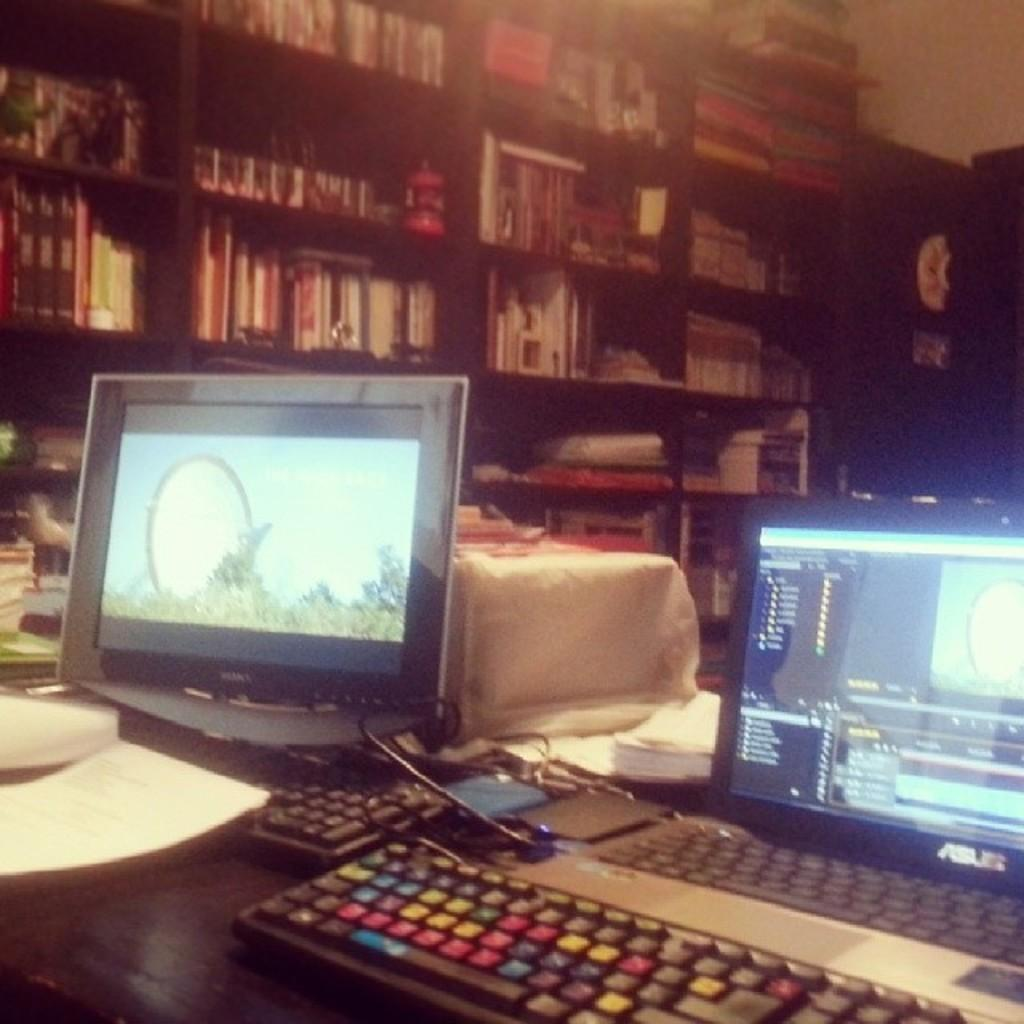What objects can be seen in the image? There are books, a table, laptops, and keyboards in the image. What surface are the laptops and keyboards placed on? The laptops and keyboards are placed on a table in the image. What might be used for typing or inputting information in the image? The keyboards on the table can be used for typing or inputting information. What type of authority figure can be seen in the image? There is no authority figure present in the image; it features books, a table, laptops, and keyboards. What time does the clock in the image show? There is no clock present in the image. Can you describe the beetle crawling on the table in the image? There is no beetle present in the image; it features books, a table, laptops, and keyboards. 